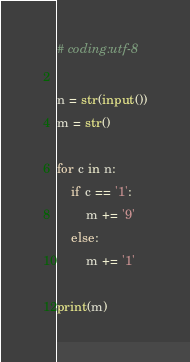Convert code to text. <code><loc_0><loc_0><loc_500><loc_500><_Python_># coding:utf-8

n = str(input())
m = str()

for c in n:
    if c == '1':
        m += '9'
    else:
        m += '1'

print(m)</code> 